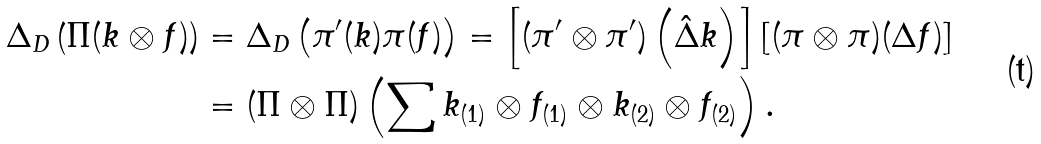Convert formula to latex. <formula><loc_0><loc_0><loc_500><loc_500>\Delta _ { D } \left ( \Pi ( k \otimes f ) \right ) & = \Delta _ { D } \left ( \pi ^ { \prime } ( k ) \pi ( f ) \right ) = \left [ ( \pi ^ { \prime } \otimes \pi ^ { \prime } ) \left ( \hat { \Delta } k \right ) \right ] \left [ ( \pi \otimes \pi ) ( \Delta f ) \right ] \\ & = ( \Pi \otimes \Pi ) \left ( \sum k _ { ( 1 ) } \otimes f _ { ( 1 ) } \otimes k _ { ( 2 ) } \otimes f _ { ( 2 ) } \right ) .</formula> 